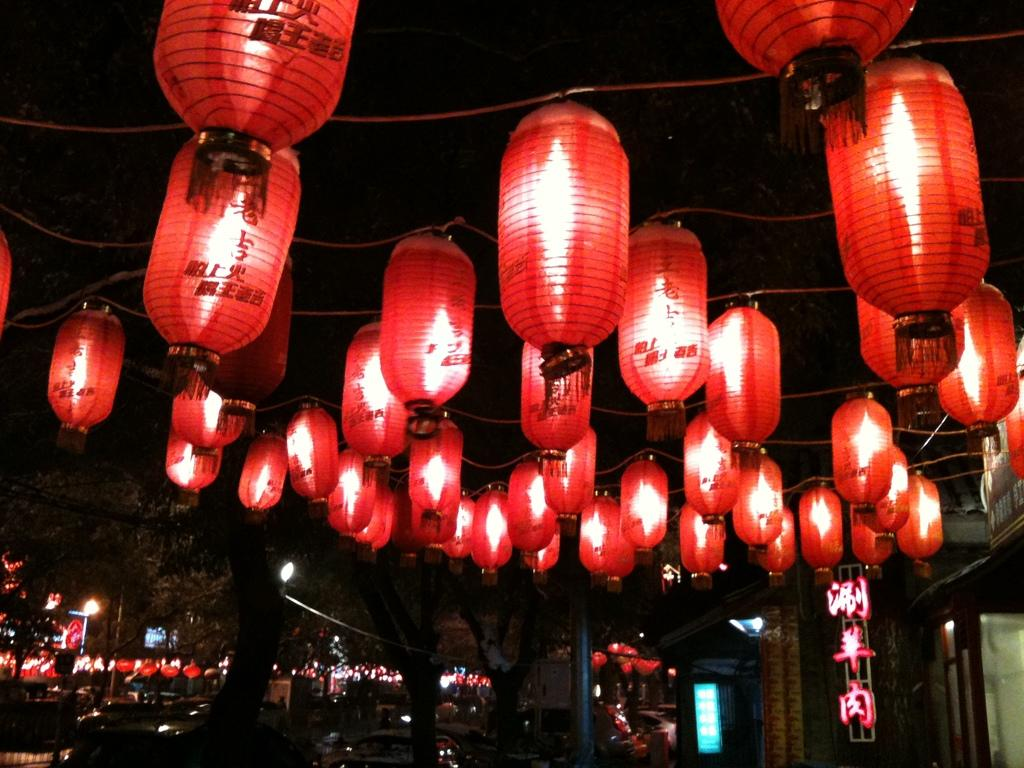What type of lighting is present in the image? There are decorative lights in the image. How are the lights arranged or positioned? The lights are hanged on wires. What else can be seen in the image besides the lights? There is a board visible in the image, as well as trees in the background and vehicles on a path. What type of berry is hanging from the wires in the image? There are no berries present in the image; the lights are hung on wires. What is the weight of the string used to hang the lights in the image? There is no mention of a string being used to hang the lights in the image, and even if there were, it would not be possible to determine its weight from the image alone. 